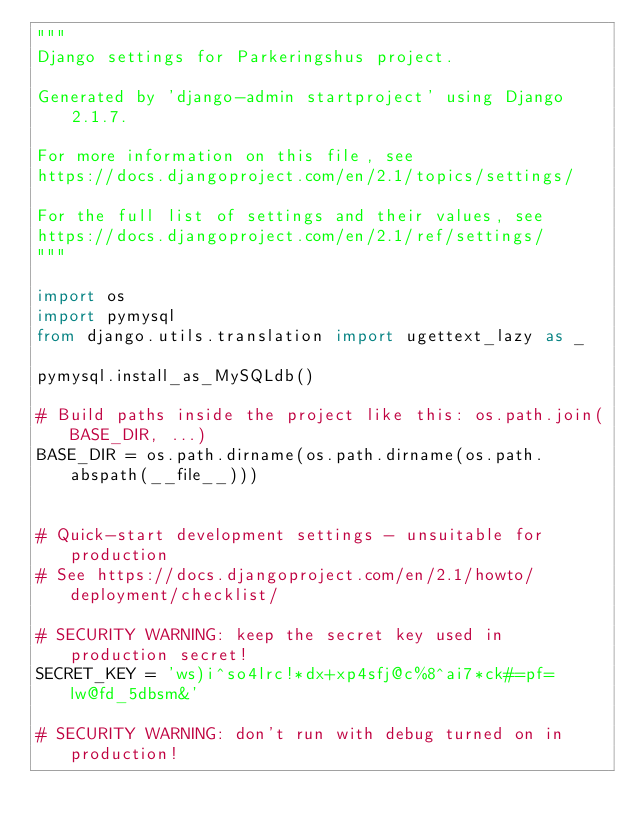Convert code to text. <code><loc_0><loc_0><loc_500><loc_500><_Python_>"""
Django settings for Parkeringshus project.

Generated by 'django-admin startproject' using Django 2.1.7.

For more information on this file, see
https://docs.djangoproject.com/en/2.1/topics/settings/

For the full list of settings and their values, see
https://docs.djangoproject.com/en/2.1/ref/settings/
"""

import os
import pymysql
from django.utils.translation import ugettext_lazy as _

pymysql.install_as_MySQLdb()

# Build paths inside the project like this: os.path.join(BASE_DIR, ...)
BASE_DIR = os.path.dirname(os.path.dirname(os.path.abspath(__file__)))


# Quick-start development settings - unsuitable for production
# See https://docs.djangoproject.com/en/2.1/howto/deployment/checklist/

# SECURITY WARNING: keep the secret key used in production secret!
SECRET_KEY = 'ws)i^so4lrc!*dx+xp4sfj@c%8^ai7*ck#=pf=lw@fd_5dbsm&'

# SECURITY WARNING: don't run with debug turned on in production!</code> 